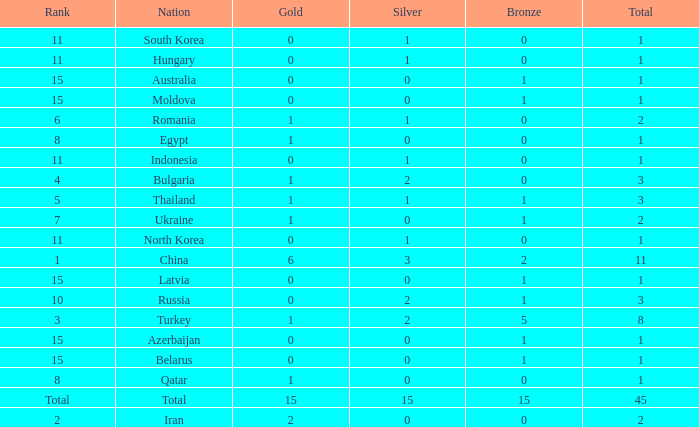What is the sum of the bronze medals of the nation with less than 0 silvers? None. 